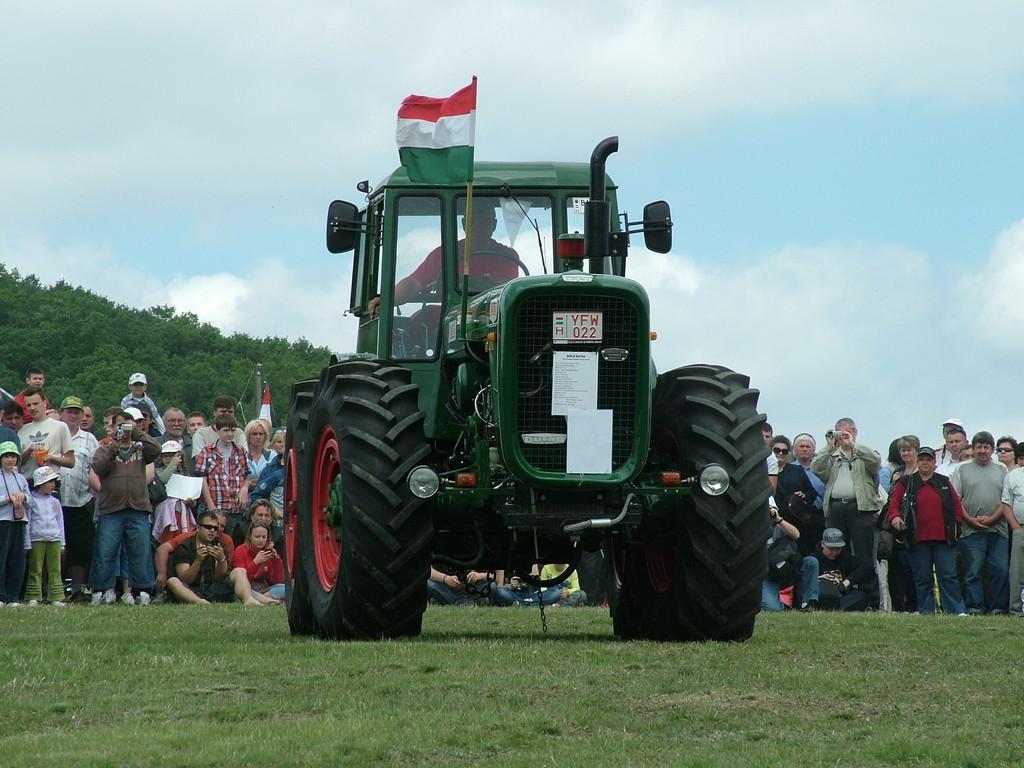Please provide a concise description of this image. In this image I can see an open grass ground and on it I can see a green colour vehicle in the front. On this vehicle I can see few boards, a flag and in it I can see one person is sitting. I can also see something is written on these boards. In the background I can see number of people where few are sitting on the ground and rest all are standing. I can also see number of trees, clouds and the sky in the background. 